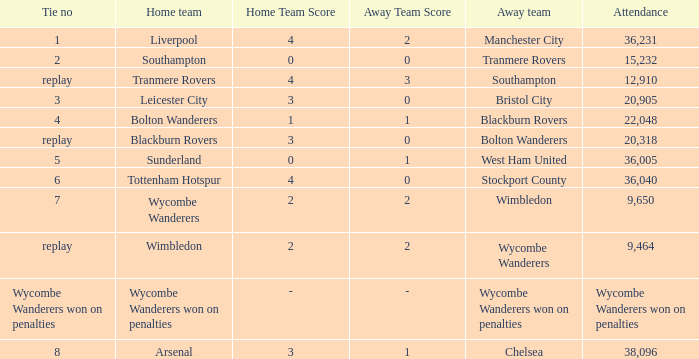What was the score for the match where the home team was Leicester City? 3 – 0. 